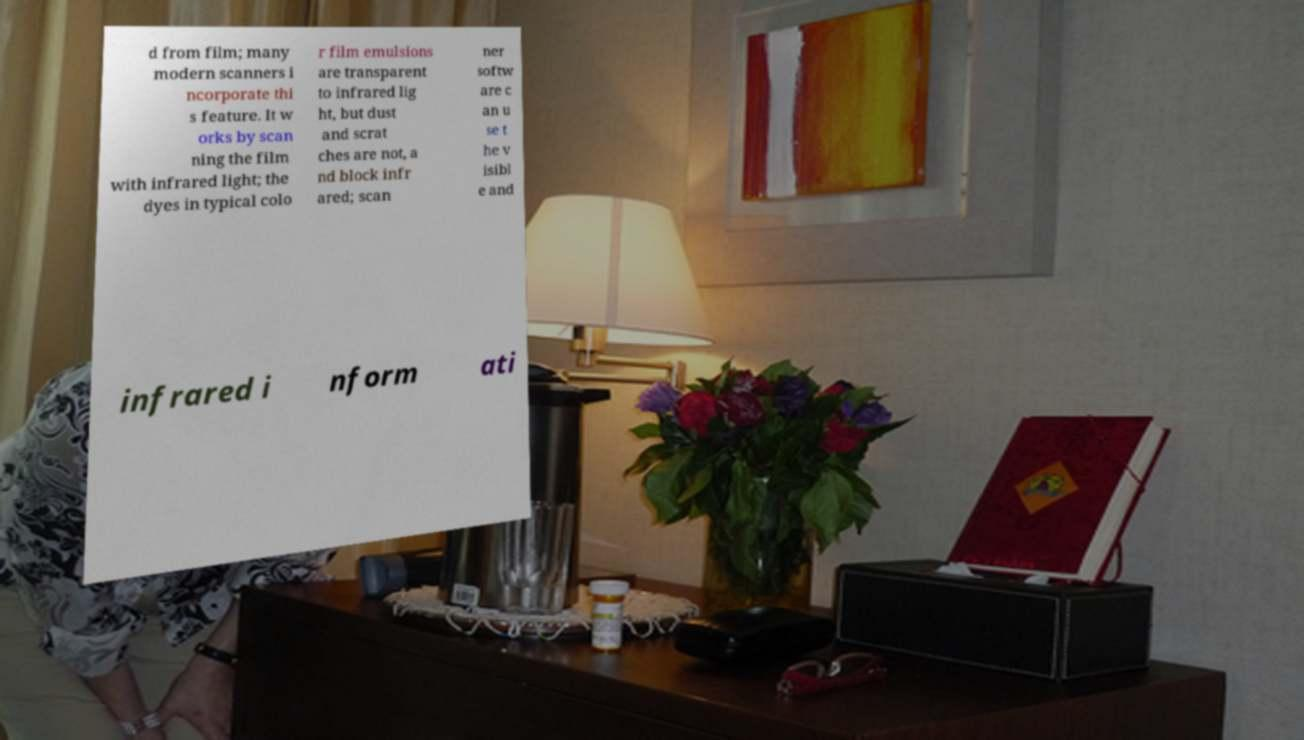Could you assist in decoding the text presented in this image and type it out clearly? d from film; many modern scanners i ncorporate thi s feature. It w orks by scan ning the film with infrared light; the dyes in typical colo r film emulsions are transparent to infrared lig ht, but dust and scrat ches are not, a nd block infr ared; scan ner softw are c an u se t he v isibl e and infrared i nform ati 